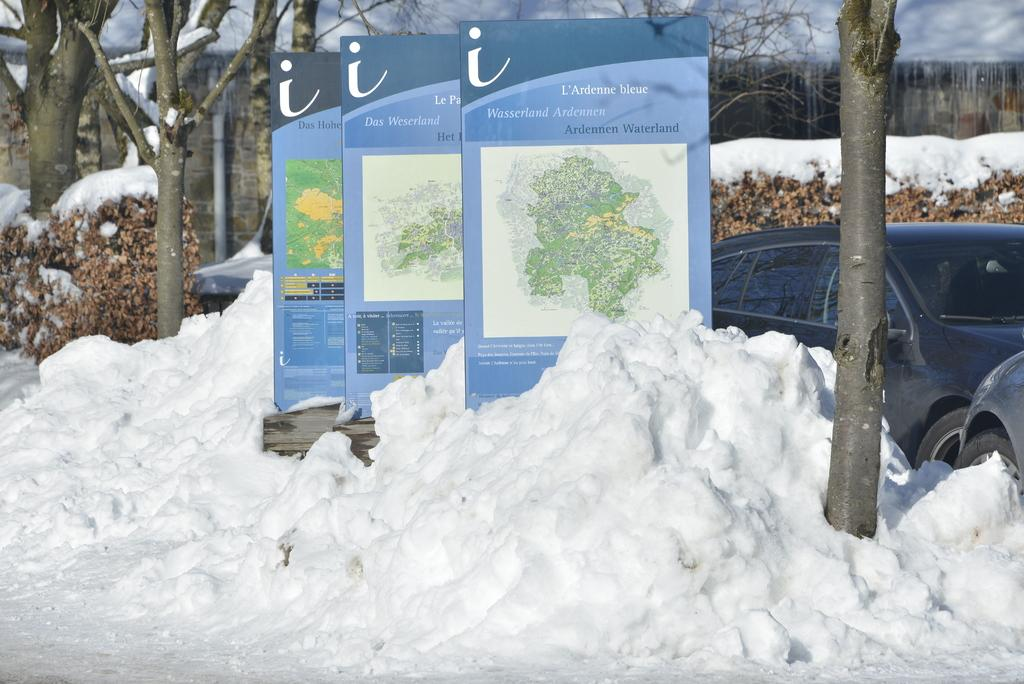What type of vehicles can be seen in the image? There are cars in the image. What is the weather condition in the image? There is snow visible in the image. What decorative elements are present in the image? There are banners in the image. What type of natural elements can be seen in the image? There are trees in the image. What object can be seen in the background of the image? There is a pipe in the background of the image. What type of toys can be seen playing with the son in the image? There are no toys or a son present in the image. 